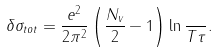<formula> <loc_0><loc_0><loc_500><loc_500>\delta \sigma _ { t o t } = \frac { e ^ { 2 } } { 2 \pi ^ { 2 } } \left ( \frac { N _ { v } } { 2 } - 1 \right ) \ln { \frac { } { T \tau } } .</formula> 